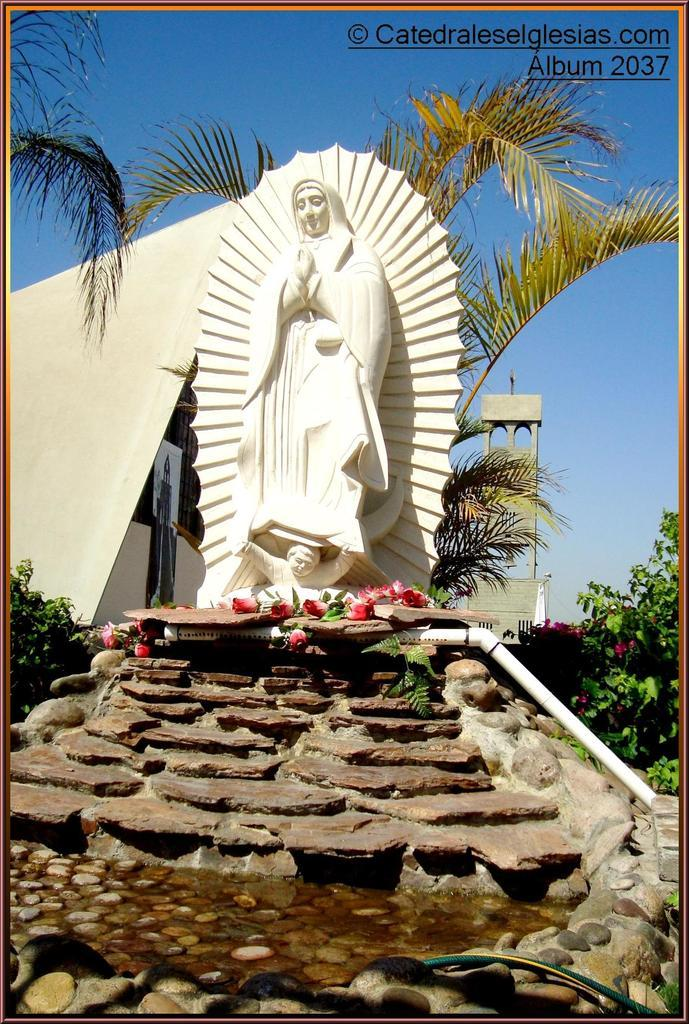What is the statue made of in the image? The statue is made of white color material, but we cannot determine if it is made of quartz from the image. What is located near the statue? White color pipes are near the statue. What type of vegetation is present near the statue? Flowers are present near the statue. What can be seen in the background of the image? There is a building, plants, and trees visible in the background. What is the color of the sky in the image? The sky is blue in the image. How many marks can be seen on the statue in the image? There is no mention of marks on the statue in the image, so we cannot determine the number of marks. Are there any trains visible in the image? There are no trains present in the image. 